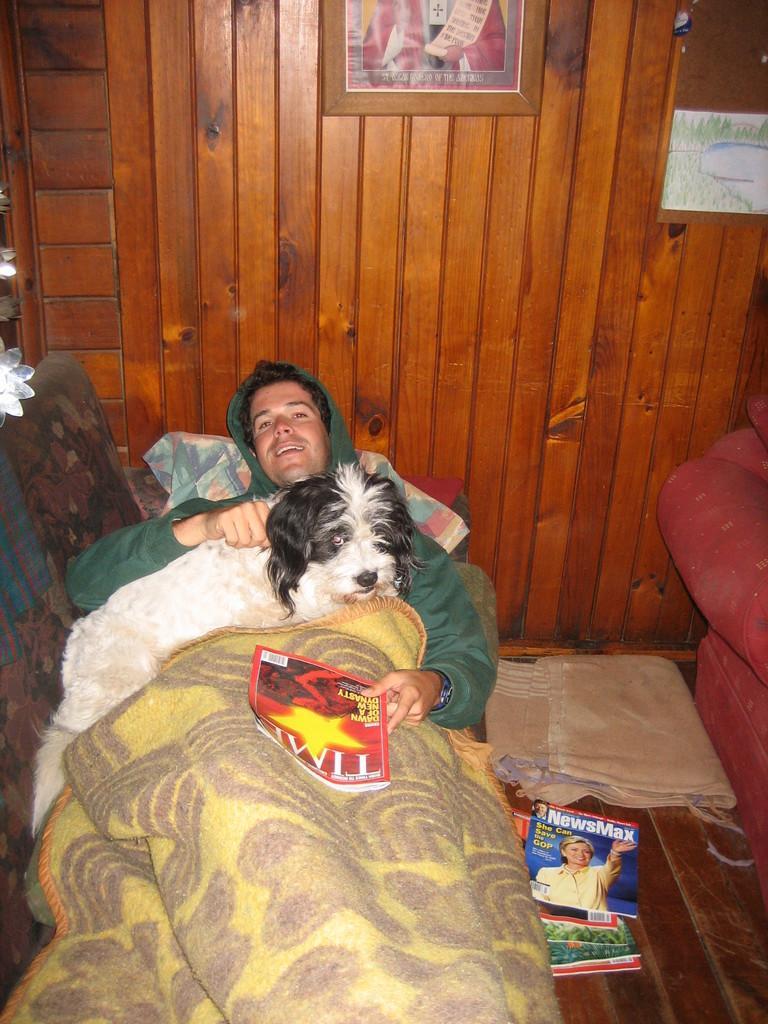In one or two sentences, can you explain what this image depicts? In this image, I can see a person lying on sofa, wearing a green color jacket, holding a Times magazine in left hand. And on the right of the middle, I can see a dog sitting on the person. In the background, I can see a wooden wall, where a photo frame is hanged. In the right of the background, I can see a wall painting. In the bottom of the background, I can see some magazines kept on the floor and a cloth. 